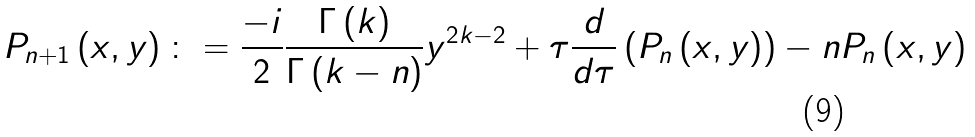Convert formula to latex. <formula><loc_0><loc_0><loc_500><loc_500>P _ { n + 1 } \left ( x , y \right ) \colon = \frac { - i } { 2 } \frac { \Gamma \left ( k \right ) } { \Gamma \left ( k - n \right ) } y ^ { 2 k - 2 } + \tau \frac { d } { d \tau } \left ( P _ { n } \left ( x , y \right ) \right ) - n P _ { n } \left ( x , y \right )</formula> 